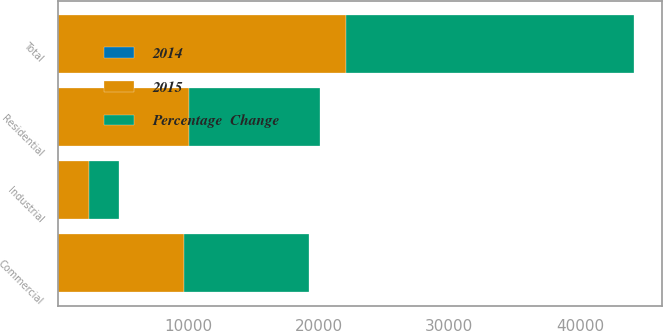Convert chart to OTSL. <chart><loc_0><loc_0><loc_500><loc_500><stacked_bar_chart><ecel><fcel>Residential<fcel>Commercial<fcel>Industrial<fcel>Total<nl><fcel>Percentage  Change<fcel>10094<fcel>9635<fcel>2342<fcel>22071<nl><fcel>2015<fcel>10026<fcel>9643<fcel>2377<fcel>22046<nl><fcel>2014<fcel>0.7<fcel>0.1<fcel>1.5<fcel>0.1<nl></chart> 